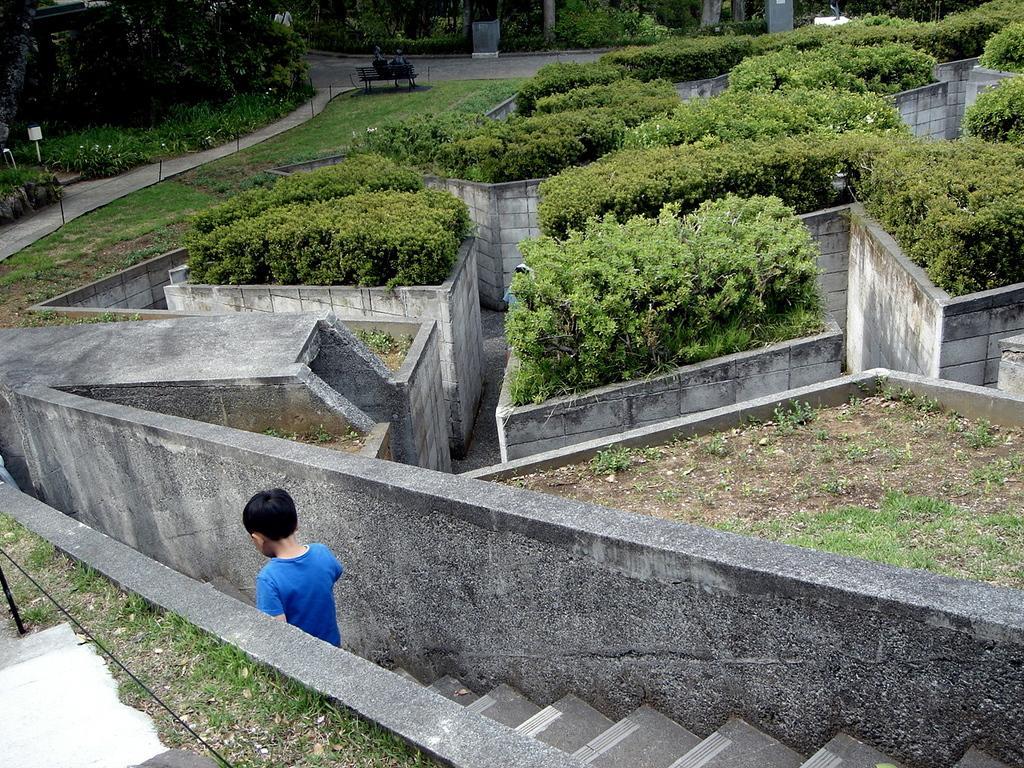Could you give a brief overview of what you see in this image? This picture shows few trees and a bench, we see grass on the ground and we see a boy getting down the stairs. 